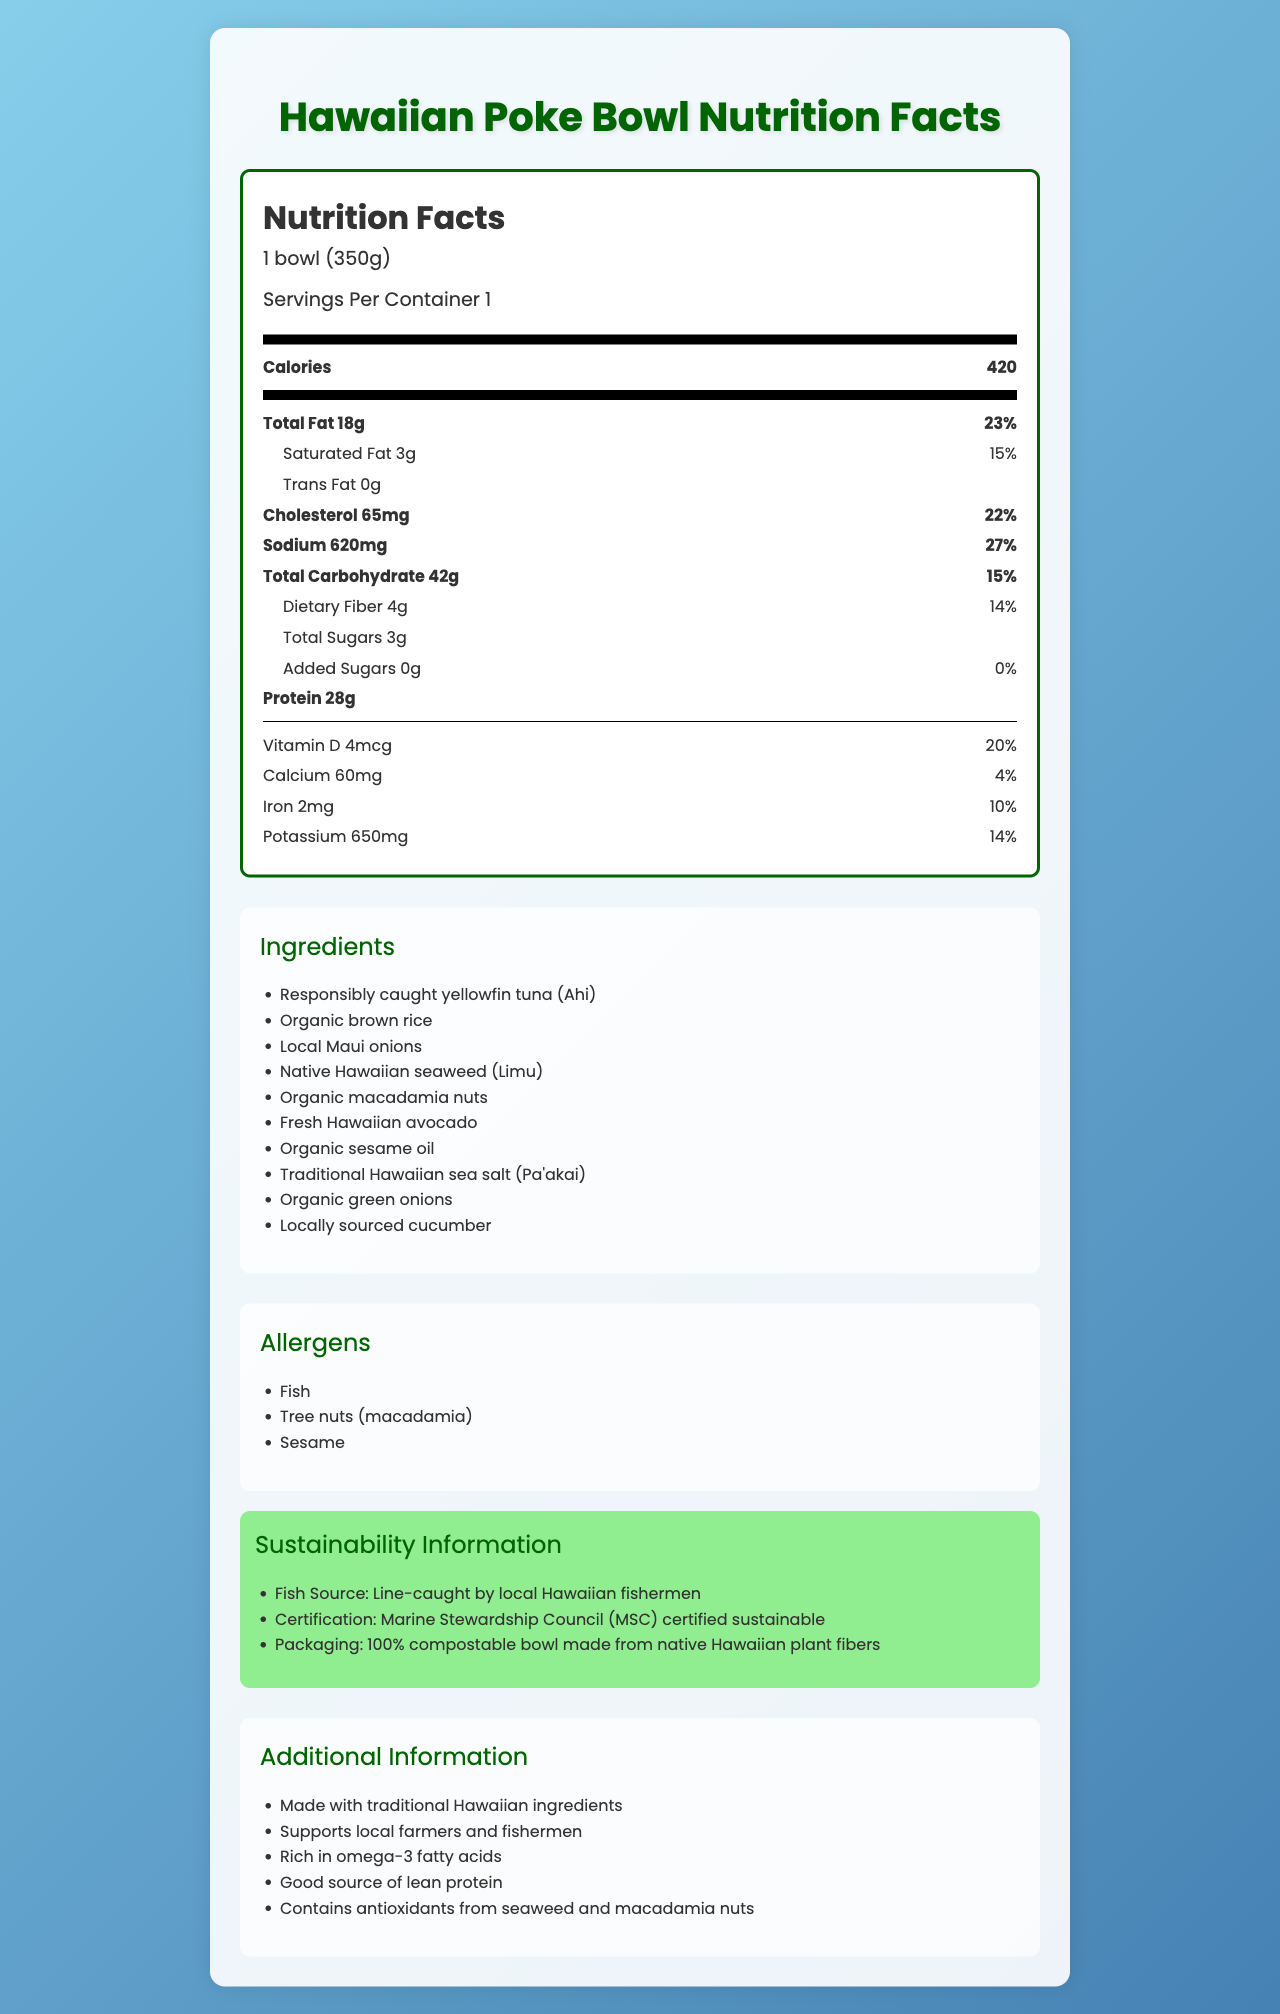what is the serving size of the poke bowl? The serving size is directly stated at the top of the nutrition label.
Answer: 1 bowl (350g) how many calories are in one serving of the poke bowl? The calorie count is listed right below the serving size information.
Answer: 420 what percentage of the daily value of total fat does the poke bowl provide? The daily value percentage for total fat is stated next to the amount of total fat.
Answer: 23% how much sodium does the poke bowl contain? The amount of sodium in milligrams is specified on the nutrition label.
Answer: 620 mg what are the main ingredients in the poke bowl? The ingredients are listed under the ingredients section.
Answer: Responsibly caught yellowfin tuna (Ahi), Organic brown rice, Local Maui onions, Native Hawaiian seaweed (Limu), Organic macadamia nuts, Fresh Hawaiian avocado, Organic sesame oil, Traditional Hawaiian sea salt (Pa'akai), Organic green onions, Locally sourced cucumber what is the daily value percentage of dietary fiber in the poke bowl? The daily value percentage for dietary fiber is provided in the nutrition facts.
Answer: 14% is there any trans fat in the poke bowl? The nutrition label indicates 0 grams of trans fat.
Answer: No does the poke bowl contain any added sugars? The nutrition label lists 0 grams of added sugars.
Answer: No which allergen is NOT present in the poke bowl? A. Dairy B. Fish C. Tree nuts D. Sesame The allergens section lists Fish, Tree nuts (macadamia), and Sesame, but not dairy.
Answer: A. Dairy how is the fish in the poke bowl sourced? A. Farm-raised B. Line-caught by local Hawaiian fishermen C. Imported from Japan The sustainability information states that the fish is line-caught by local Hawaiian fishermen.
Answer: B. Line-caught by local Hawaiian fishermen is the poke bowl packaging environmentally friendly? The sustainability section mentions the packaging is 100% compostable and made from native Hawaiian plant fibers.
Answer: Yes summarize the overall content and message of the document. The document outlines the nutritional content and ingredients of the poke bowl and highlights its sustainability aspects, emphasizing its benefits for both health and the environment.
Answer: The document provides a detailed nutrition facts label for a traditional Hawaiian poke bowl made with responsibly caught fish. It includes information on serving size, calorie content, macronutrients, micronutrients, ingredients, allergens, and the sustainable sourcing and packaging of the product. This poke bowl supports local farmers and fishermen and contains beneficial nutrients such as omega-3 fatty acids and antioxidants. what is the percentage of daily value for iron in the poke bowl? The nutrition label lists the daily value percentage for iron.
Answer: 10% does the poke bowl support local farmers and fishermen? Additional information states that the poke bowl supports local farmers and fishermen.
Answer: Yes how much protein does the poke bowl contain? The nutrition label specifies the amount of protein in grams.
Answer: 28g what is the main ecological benefit of the poke bowl mentioned in the document? The sustainability section highlights the ecological benefits by mentioning sustainable fishing practices and compostable packaging.
Answer: Supports local fishermen and uses sustainable and compostable packaging. why is vitamin D beneficial according to the document? The document mentions the amount of vitamin D but does not elaborate on its benefits.
Answer: Not enough information 